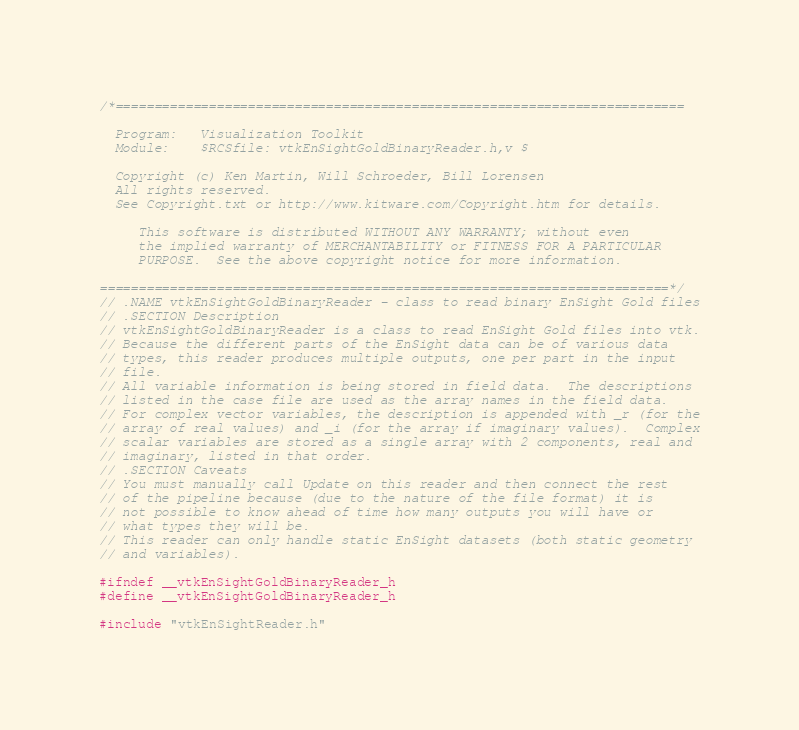Convert code to text. <code><loc_0><loc_0><loc_500><loc_500><_C_>/*=========================================================================

  Program:   Visualization Toolkit
  Module:    $RCSfile: vtkEnSightGoldBinaryReader.h,v $

  Copyright (c) Ken Martin, Will Schroeder, Bill Lorensen
  All rights reserved.
  See Copyright.txt or http://www.kitware.com/Copyright.htm for details.

     This software is distributed WITHOUT ANY WARRANTY; without even
     the implied warranty of MERCHANTABILITY or FITNESS FOR A PARTICULAR
     PURPOSE.  See the above copyright notice for more information.

=========================================================================*/
// .NAME vtkEnSightGoldBinaryReader - class to read binary EnSight Gold files
// .SECTION Description
// vtkEnSightGoldBinaryReader is a class to read EnSight Gold files into vtk.
// Because the different parts of the EnSight data can be of various data
// types, this reader produces multiple outputs, one per part in the input
// file.
// All variable information is being stored in field data.  The descriptions
// listed in the case file are used as the array names in the field data.
// For complex vector variables, the description is appended with _r (for the
// array of real values) and _i (for the array if imaginary values).  Complex
// scalar variables are stored as a single array with 2 components, real and
// imaginary, listed in that order.
// .SECTION Caveats
// You must manually call Update on this reader and then connect the rest
// of the pipeline because (due to the nature of the file format) it is
// not possible to know ahead of time how many outputs you will have or
// what types they will be.
// This reader can only handle static EnSight datasets (both static geometry
// and variables).

#ifndef __vtkEnSightGoldBinaryReader_h
#define __vtkEnSightGoldBinaryReader_h

#include "vtkEnSightReader.h"
</code> 